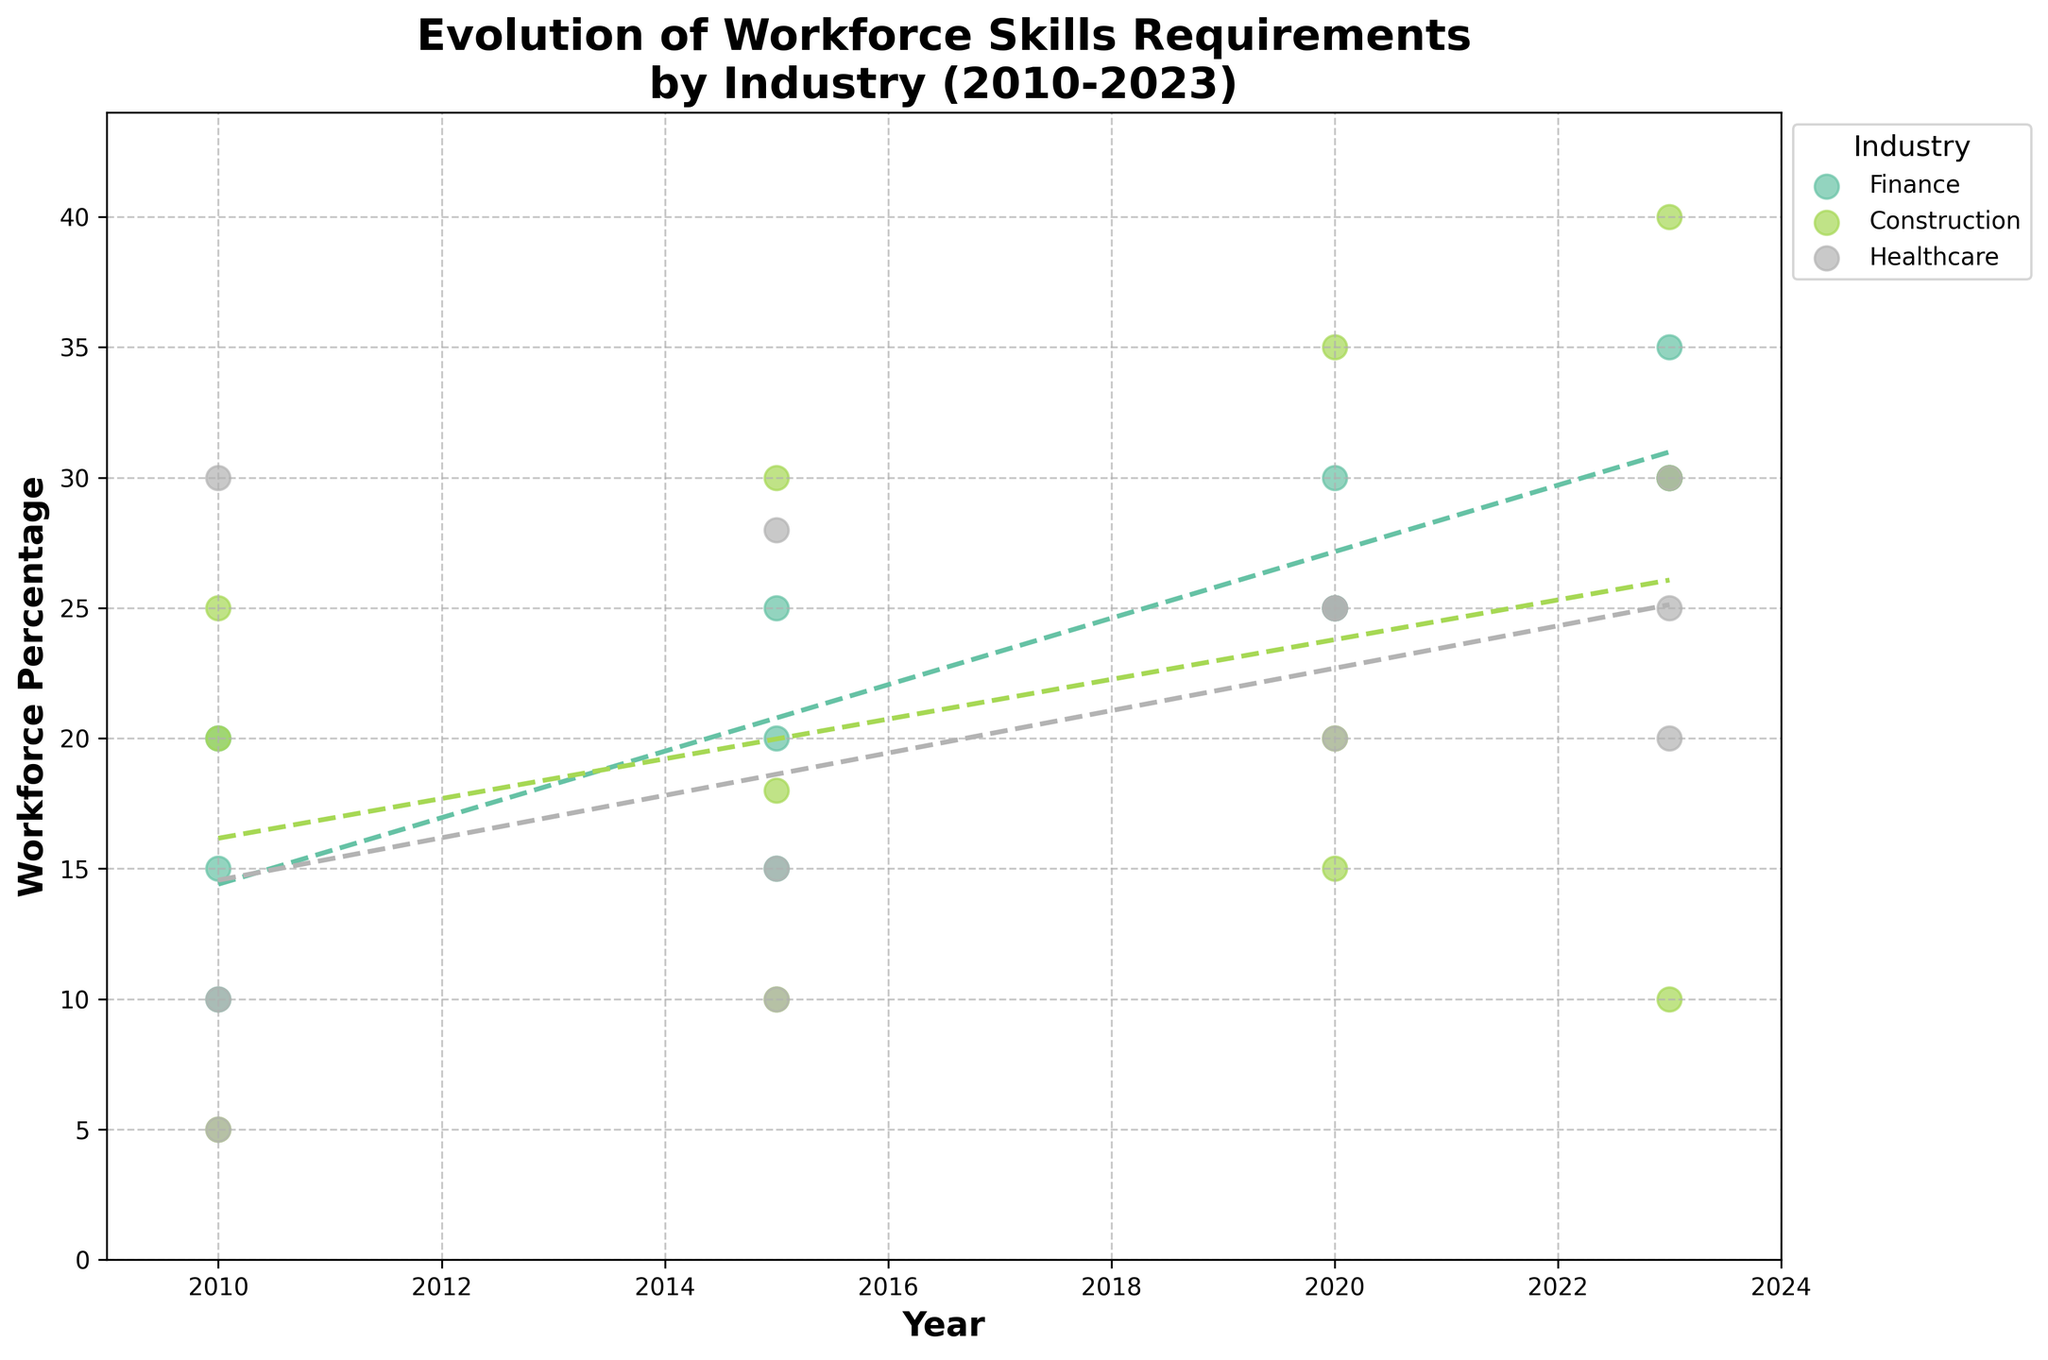What's the title of the plot? The title is usually at the top of the plot. Here, it states "Evolution of Workforce Skills Requirements\nby Industry (2010-2023)"
Answer: Evolution of Workforce Skills Requirements by Industry (2010-2023) What are the axes labeled? The x-axis is labeled "Year," and the y-axis is labeled "Workforce Percentage." These labels indicate what each axis represents.
Answer: Year, Workforce Percentage Which industry has the highest workforce percentage trend in 2023 for any skill? The scatter plot for 2023 shows multiple industries; by visually assessing, "Construction" for "Project Management" reaches 40%, the highest percentage.
Answer: Construction How has the workforce percentage for Finance: Cybersecurity changed from 2010 to 2023? Looking at the data points for "Finance" in 2010 and 2023 for "Cybersecurity," it starts at 10% in 2010 and rises to 30% in 2023. The change is 30%-10% = 20%.
Answer: Increased by 20% Which industry shows the steepest increase in workforce percentage for any skill? By comparing the slopes of the trend lines, "Construction" for "Green Building Techniques" sees a significant rise, suggesting the steepest increase.
Answer: Construction How does the workforce percentage trend for Healthcare: Telehealth compare between 2010 and 2023? The 2010 percentage starts at 5% and rises to 30% in 2023, showing a significant increase over the years.
Answer: Increased What is the average workforce percentage for Finance: Compliance across the years? The workforce percentages for "Finance: Compliance" are 20, 25, 30, and 35. Summing these (20 + 25 + 30 + 35) and dividing by 4 gives the average: 110 / 4 = 27.5%
Answer: 27.5% In which year does Construction: Green Building Techniques see the most notable increase from the previous year? Observing the scatter plot points for "Construction: Green Building Techniques,” the most significant increase occurs between 2015 (10%) and 2020 (20%), an increase of 10%.
Answer: 2020 How do the workforce percentages for Healthcare: Health Informatics in 2020 and 2023 compare? From the scatter plot data points, Healthcare: Health Informatics shows 20% in 2020 and 25% in 2023, indicating an increase.
Answer: 2023 > 2020 Which industry and skill show no increase in workforce percentage from 2010 to 2023? In the scatter plot, "Construction: Technical Drawing" decreases from 20% in 2010 to 10% in 2023.
Answer: Construction: Technical Drawing 